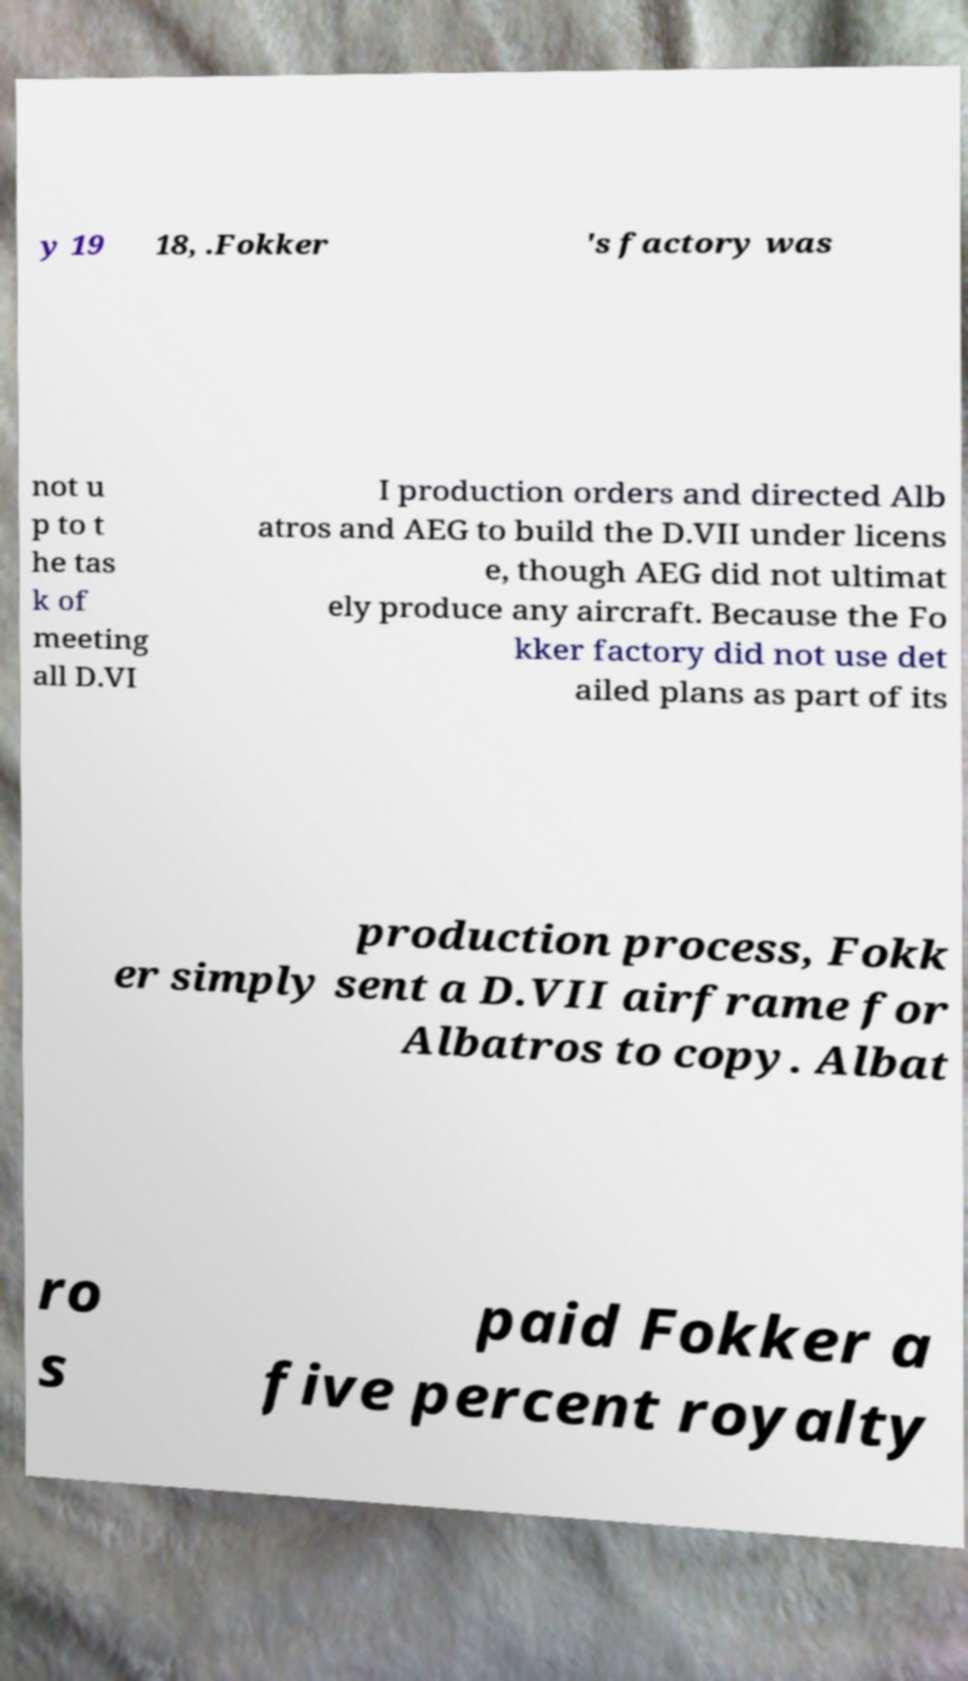There's text embedded in this image that I need extracted. Can you transcribe it verbatim? y 19 18, .Fokker 's factory was not u p to t he tas k of meeting all D.VI I production orders and directed Alb atros and AEG to build the D.VII under licens e, though AEG did not ultimat ely produce any aircraft. Because the Fo kker factory did not use det ailed plans as part of its production process, Fokk er simply sent a D.VII airframe for Albatros to copy. Albat ro s paid Fokker a five percent royalty 